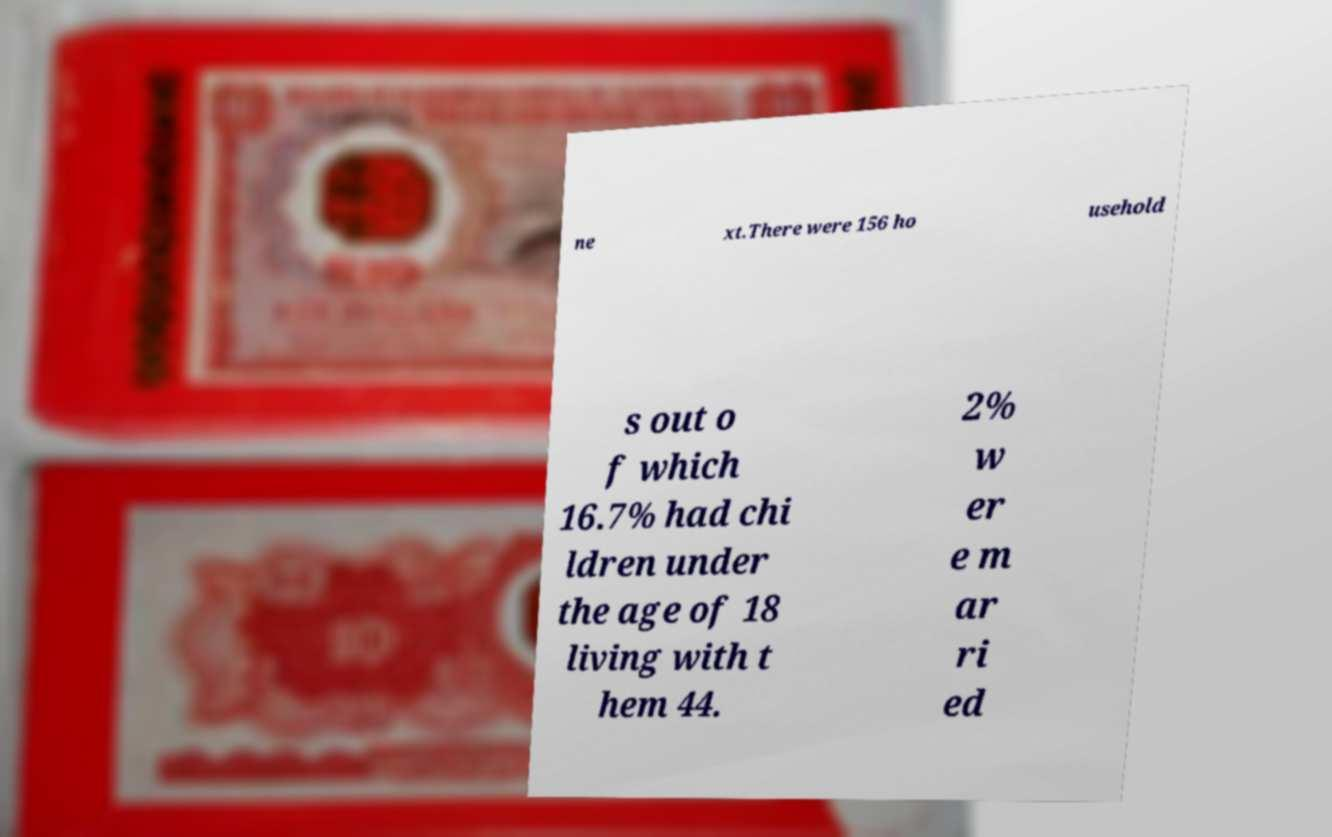What messages or text are displayed in this image? I need them in a readable, typed format. ne xt.There were 156 ho usehold s out o f which 16.7% had chi ldren under the age of 18 living with t hem 44. 2% w er e m ar ri ed 